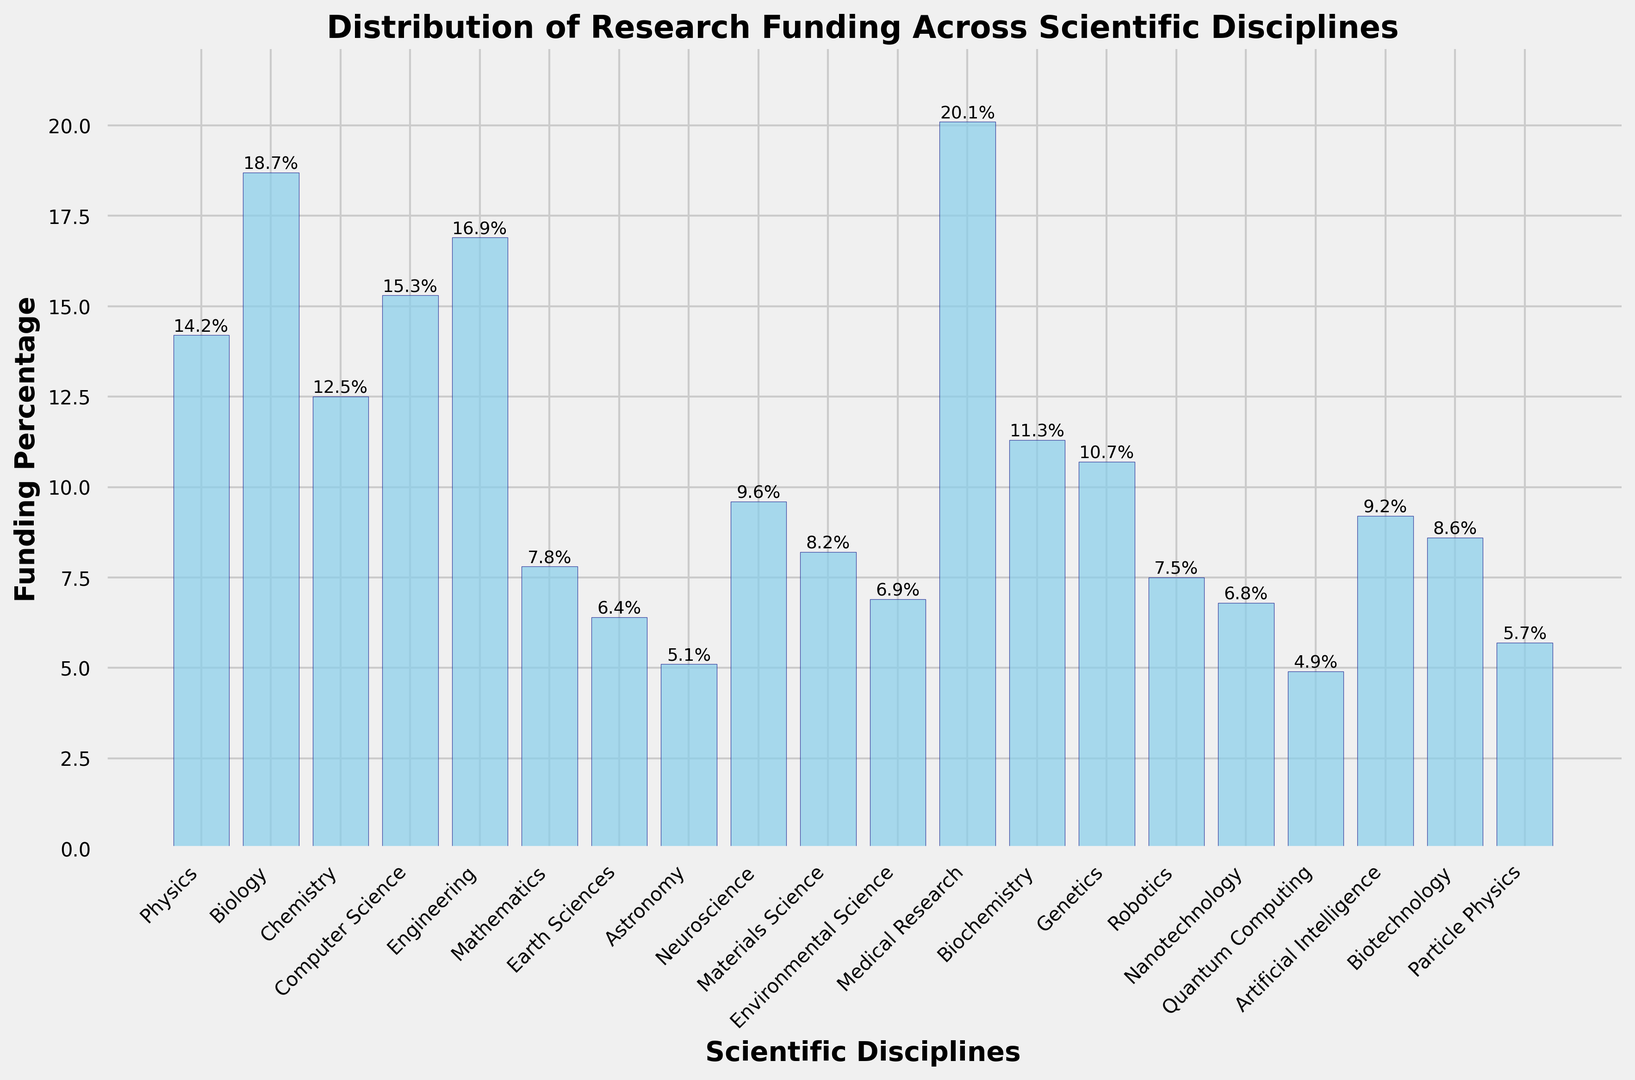What discipline receives the highest percentage of research funding? The bar with the highest height represents the discipline with the highest percentage of research funding.
Answer: Medical Research Which discipline gets less funding: Mathematics or Artificial Intelligence? By comparing the heights of the bars, Mathematics has a lower percentage than Artificial Intelligence.
Answer: Mathematics What is the total percentage of funding for Physics, Chemistry, and Biology combined? Add the percentages for Physics (14.2%), Chemistry (12.5%), and Biology (18.7%): 14.2 + 12.5 + 18.7 = 45.4%
Answer: 45.4% How much more funding does Computer Science receive compared to Genetics? Subtract the percentage for Genetics (10.7%) from the percentage for Computer Science (15.3%): 15.3 - 10.7 = 4.6%
Answer: 4.6% Are there any disciplines that receive exactly or less than 5% funding? If so, name them. Check the disciplines with bars that reach or are below 5% on the y-axis. Quantum Computing and Astronomy both have funding percentages equal to or below 5%.
Answer: Quantum Computing, Astronomy Which discipline receives the second highest percentage of research funding? From the heights of the bars, the second highest bar after Medical Research is for Biology.
Answer: Biology What's the combined funding percentage for all engineering-related disciplines (Engineering, Materials Science, and Nanotechnology)? Sum the percentages for Engineering (16.9%), Materials Science (8.2%), and Nanotechnology (6.8%): 16.9 + 8.2 + 6.8 = 31.9%
Answer: 31.9% Which disciplines receive more than 15% research funding? Identify the bars that extend above the 15% mark on the y-axis. These are Biology, Computer Science, Engineering, and Medical Research.
Answer: Biology, Computer Science, Engineering, Medical Research Compare the funding percentage of Neuroscience to that of Artificial Intelligence. Which one is higher? Look at the heights of the bars for Neuroscience (9.6%) and Artificial Intelligence (9.2%). Neuroscience has a higher percentage.
Answer: Neuroscience 